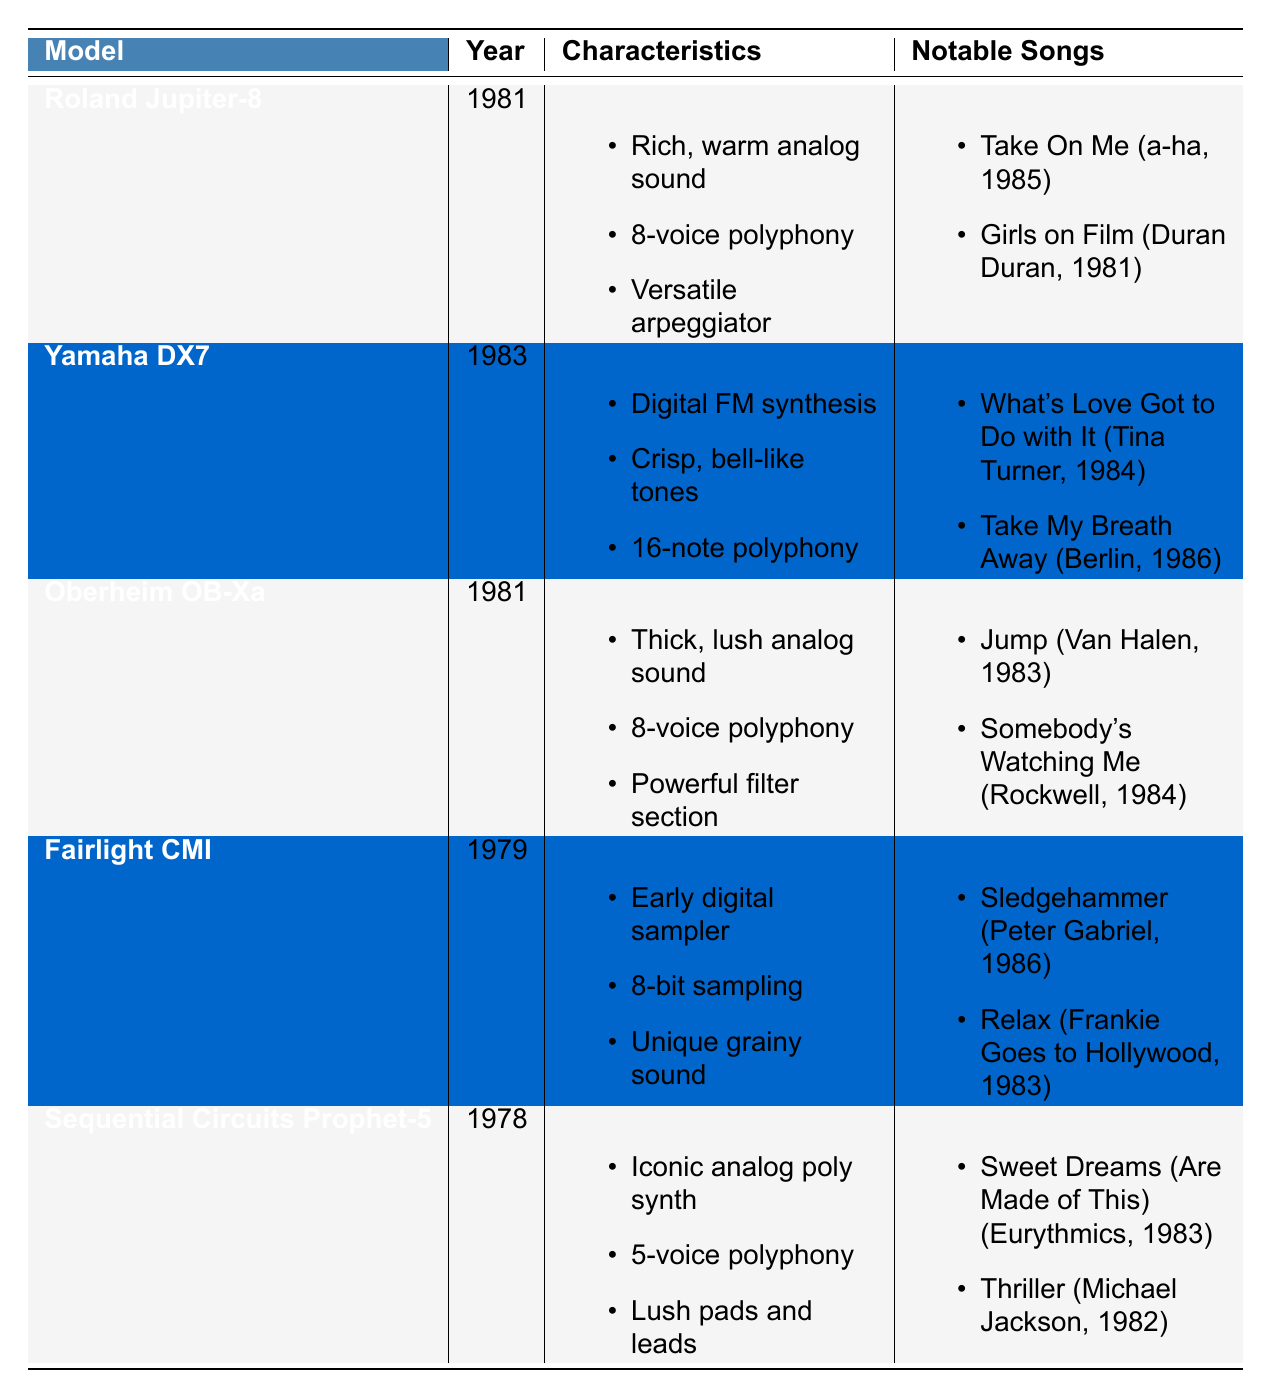What year was the Roland Jupiter-8 released? By looking at the table, we can see that the Roland Jupiter-8 was introduced in the year 1981.
Answer: 1981 Which synthesizer model has 16-note polyphony? The table indicates that the Yamaha DX7 has a polyphony of 16 notes, as listed in its characteristics.
Answer: Yamaha DX7 Does the Fairlight CMI have an analog sound? The characteristics of the Fairlight CMI describe it as an early digital sampler with an 8-bit sampling and unique grainy sound, implying it does not have a typical analog sound.
Answer: No What is the total number of notable songs attributed to the Oberheim OB-Xa and the Sequential Circuits Prophet-5? The Oberheim OB-Xa has 2 notable songs and the Sequential Circuits Prophet-5 also has 2 notable songs, giving a total of 2 + 2 = 4 notable songs.
Answer: 4 Which synthesizer was used in the song "Take My Breath Away" and what are its characteristics? The table shows that the Yamaha DX7 was used in "Take My Breath Away," and its characteristics include digital FM synthesis, crisp bell-like tones, and 16-note polyphony.
Answer: Yamaha DX7: Digital FM synthesis, crisp bell-like tones, 16-note polyphony What characteristics are shared between the Roland Jupiter-8 and the Oberheim OB-Xa? Both synthesizers have an 8-voice polyphony and feature rich, warm, or lush analog sounds, making them similar in capacity and sound quality.
Answer: 8-voice polyphony and analog sound Which artist collaborated with the Fairlight CMI for a song released in 1986? The table lists Peter Gabriel as the artist associated with the Fairlight CMI for the song "Sledgehammer," which was released in 1986.
Answer: Peter Gabriel How many synthesizers were released in or after 1983? Looking at the table, the Yamaha DX7 (1983) and Oberheim OB-Xa (1981) count as two synthesizers; however, only the Yamaha DX7 has a release date of 1983 or later.
Answer: 1 What is the range of years for the synthesizers listed in the table? The earliest synthesizer listed is the Sequential Circuits Prophet-5, released in 1978, and the latest is the Yamaha DX7, released in 1983, giving us a range from 1978 to 1983.
Answer: 1978 to 1983 Which synthesizer has the unique characteristic of being one of the first digital samplers? The Fairlight CMI is recognized as one of the first digital samplers, as mentioned in its characteristics.
Answer: Fairlight CMI How many notable songs did Duran Duran produce with the Roland Jupiter-8? Duran Duran produced one notable song with the Roland Jupiter-8, which is "Girls on Film," identified in the table.
Answer: 1 